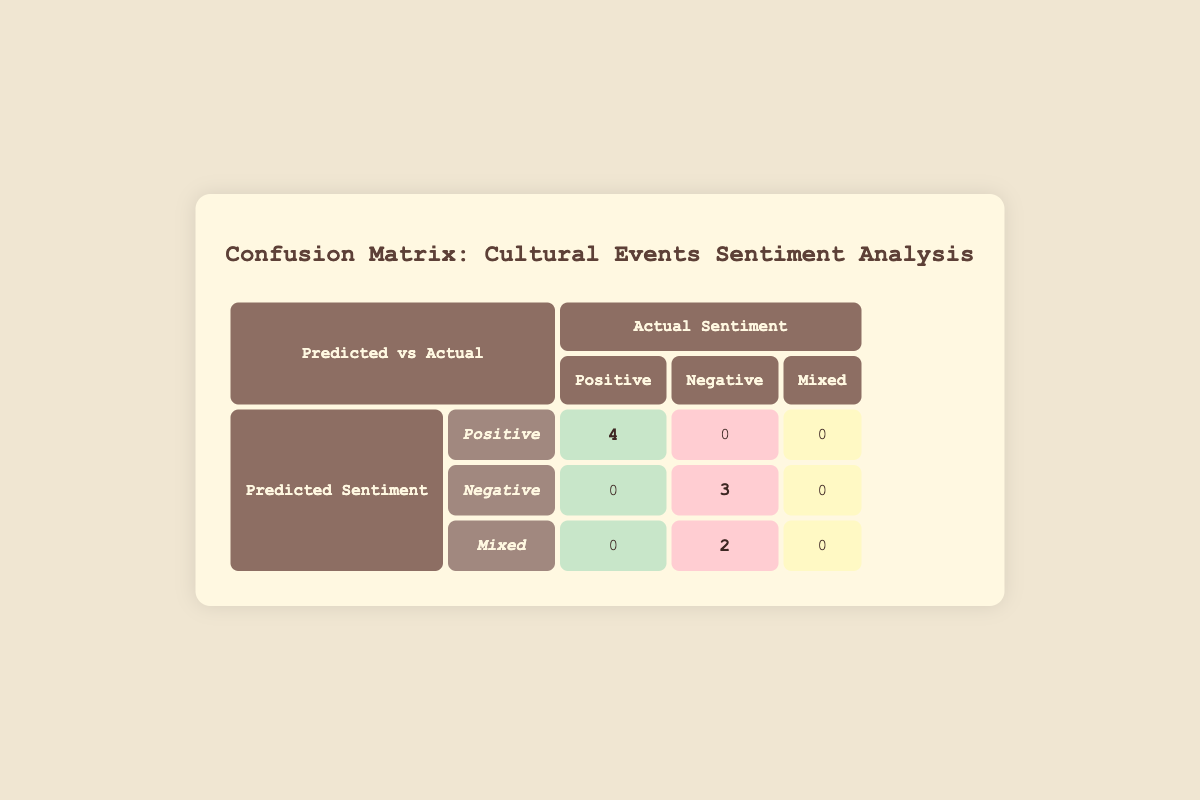What is the predicted sentiment for the "Paris Fashion Week 2023"? According to the table, the predicted sentiment for the "Paris Fashion Week 2023" is classified as "Positive."
Answer: Positive How many events had a predicted sentiment of "Negative"? The table shows that there are 3 events with a predicted sentiment of "Negative," which includes "Pride Parade 2023," "Bonnaroo Music Festival," and "Oktoberfest 2023."
Answer: 3 What is the total number of instances where the actual sentiment was "Positive"? From the table, we count the instances in the 'actual sentiment' column for "Positive," which are 4 events: "Paris Fashion Week 2023," "Dia de los Muertos Celebration," "Chinese New Year Festival," and "Holi Festival."
Answer: 4 Is it true that all events predicted as "Mixed" had a corresponding actual sentiment of "Negative"? Referring to the table, there are 2 events predicted as "Mixed." Out of these, one event, "Indian Diwali Festival," had an actual sentiment of "Negative," but "Burning Man 2023," which had a predicted sentiment of "Mixed," was also classified as "Negative." Hence, it is true.
Answer: Yes Which predicted sentiment had the highest number of correct predictions? By evaluating the table, the predicted sentiment of "Positive" had the highest number of correct predictions (4), compared to "Negative" (3) and "Mixed" (0).
Answer: Positive 